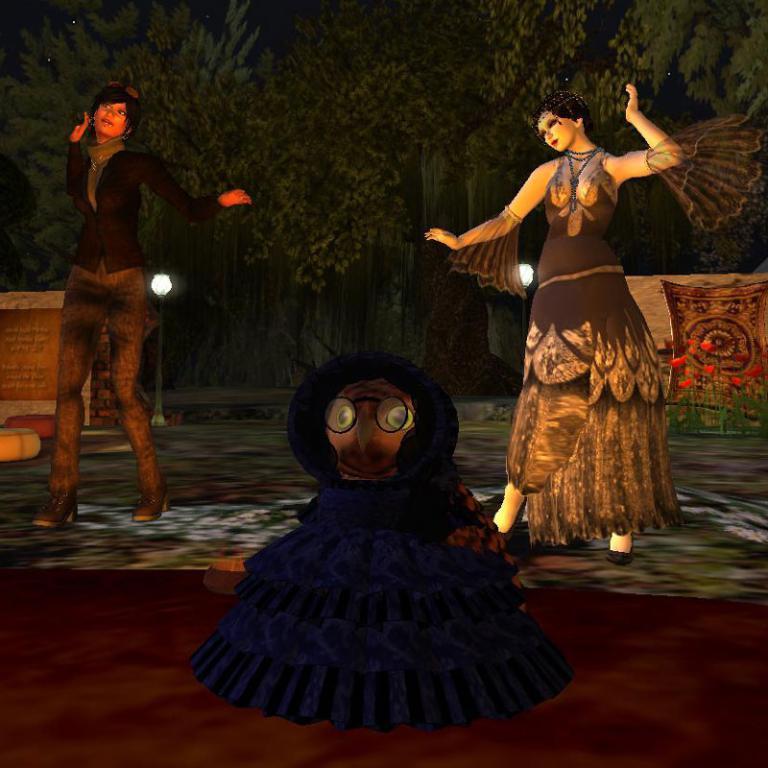In one or two sentences, can you explain what this image depicts? This is an animated image. In this image, I can see two women are dancing. In the foreground there is a toy. In the background there are some trees. 